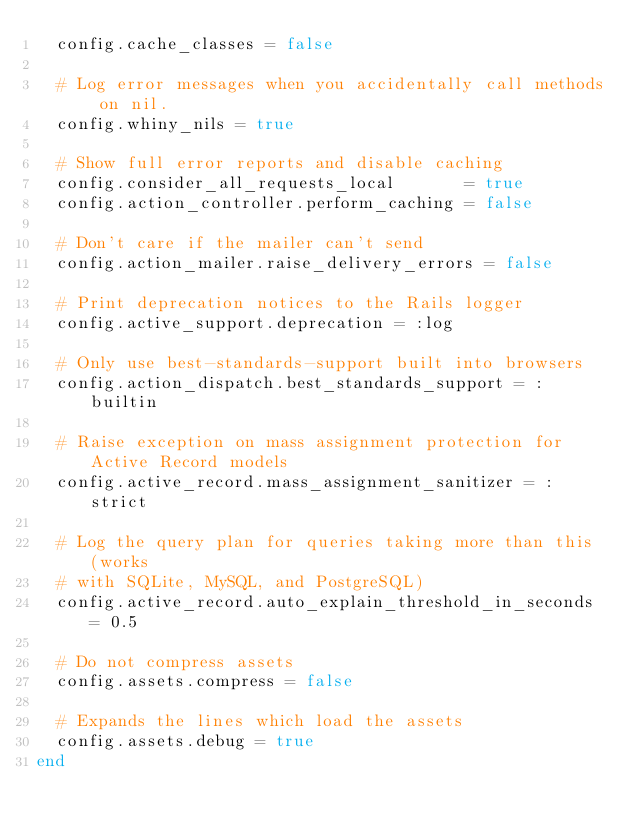<code> <loc_0><loc_0><loc_500><loc_500><_Ruby_>  config.cache_classes = false

  # Log error messages when you accidentally call methods on nil.
  config.whiny_nils = true

  # Show full error reports and disable caching
  config.consider_all_requests_local       = true
  config.action_controller.perform_caching = false

  # Don't care if the mailer can't send
  config.action_mailer.raise_delivery_errors = false

  # Print deprecation notices to the Rails logger
  config.active_support.deprecation = :log

  # Only use best-standards-support built into browsers
  config.action_dispatch.best_standards_support = :builtin

  # Raise exception on mass assignment protection for Active Record models
  config.active_record.mass_assignment_sanitizer = :strict

  # Log the query plan for queries taking more than this (works
  # with SQLite, MySQL, and PostgreSQL)
  config.active_record.auto_explain_threshold_in_seconds = 0.5

  # Do not compress assets
  config.assets.compress = false

  # Expands the lines which load the assets
  config.assets.debug = true
end
</code> 